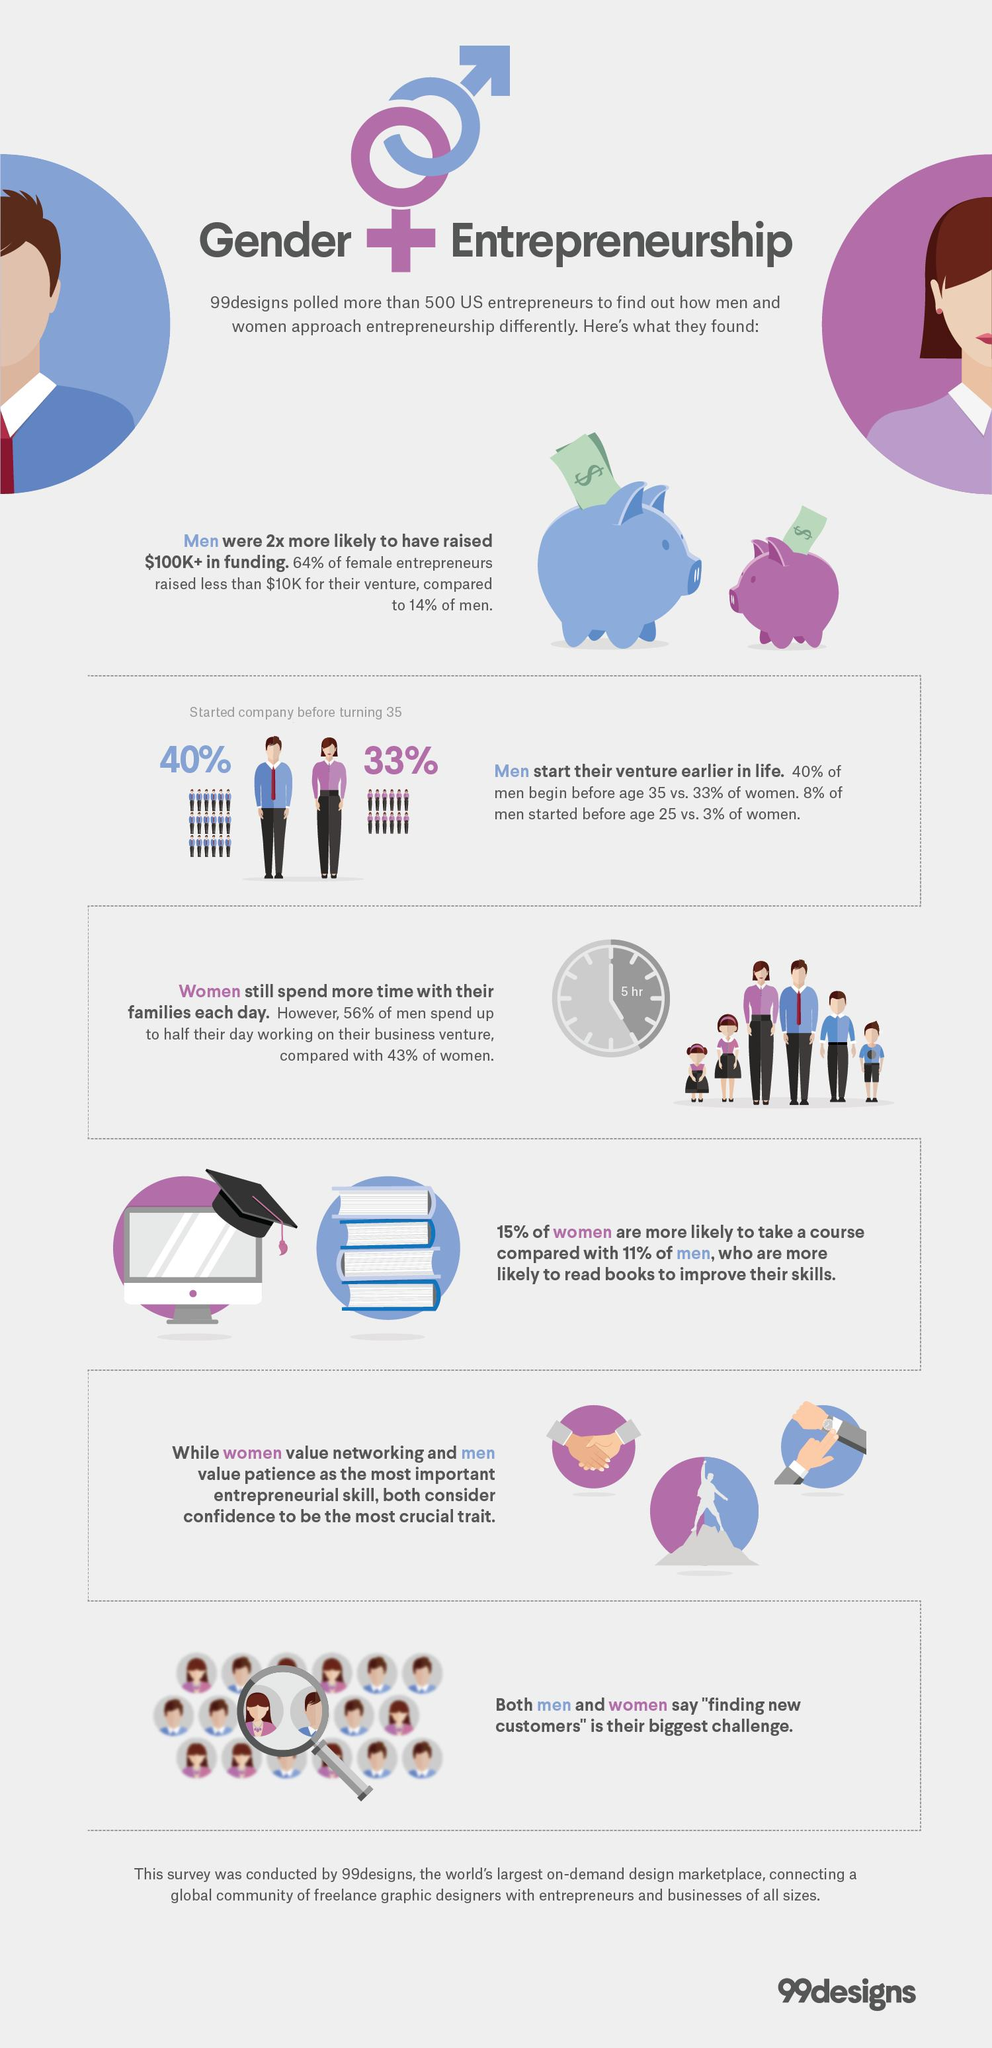Draw attention to some important aspects in this diagram. According to a recent survey, 43% of women in the United States spend half of their workday on their business venture. According to a recent study, 33% of U.S. entrepreneurs who started a company before the age of 35 are women. According to the given information, 40% of U.S. entrepreneurs who started a company before the age of 35 are men. 